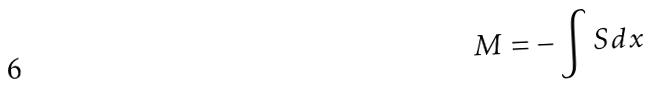Convert formula to latex. <formula><loc_0><loc_0><loc_500><loc_500>M = - \int S d x</formula> 